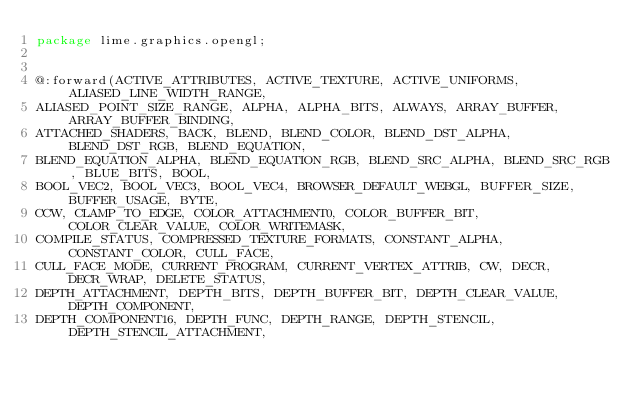<code> <loc_0><loc_0><loc_500><loc_500><_Haxe_>package lime.graphics.opengl;


@:forward(ACTIVE_ATTRIBUTES, ACTIVE_TEXTURE, ACTIVE_UNIFORMS, ALIASED_LINE_WIDTH_RANGE, 
ALIASED_POINT_SIZE_RANGE, ALPHA, ALPHA_BITS, ALWAYS, ARRAY_BUFFER, ARRAY_BUFFER_BINDING, 
ATTACHED_SHADERS, BACK, BLEND, BLEND_COLOR, BLEND_DST_ALPHA, BLEND_DST_RGB, BLEND_EQUATION, 
BLEND_EQUATION_ALPHA, BLEND_EQUATION_RGB, BLEND_SRC_ALPHA, BLEND_SRC_RGB, BLUE_BITS, BOOL, 
BOOL_VEC2, BOOL_VEC3, BOOL_VEC4, BROWSER_DEFAULT_WEBGL, BUFFER_SIZE, BUFFER_USAGE, BYTE, 
CCW, CLAMP_TO_EDGE, COLOR_ATTACHMENT0, COLOR_BUFFER_BIT, COLOR_CLEAR_VALUE, COLOR_WRITEMASK, 
COMPILE_STATUS, COMPRESSED_TEXTURE_FORMATS, CONSTANT_ALPHA, CONSTANT_COLOR, CULL_FACE, 
CULL_FACE_MODE, CURRENT_PROGRAM, CURRENT_VERTEX_ATTRIB, CW, DECR, DECR_WRAP, DELETE_STATUS, 
DEPTH_ATTACHMENT, DEPTH_BITS, DEPTH_BUFFER_BIT, DEPTH_CLEAR_VALUE, DEPTH_COMPONENT, 
DEPTH_COMPONENT16, DEPTH_FUNC, DEPTH_RANGE, DEPTH_STENCIL, DEPTH_STENCIL_ATTACHMENT, </code> 